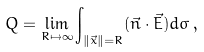Convert formula to latex. <formula><loc_0><loc_0><loc_500><loc_500>Q = \lim _ { R \mapsto \infty } \int _ { \| \vec { x } \| = R } ( \vec { n } \cdot \vec { E } ) d \sigma \, ,</formula> 